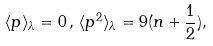<formula> <loc_0><loc_0><loc_500><loc_500>\langle p \rangle _ { \lambda } = 0 \, , \, \langle p ^ { 2 } \rangle _ { \lambda } = 9 ( n + \frac { 1 } { 2 } ) ,</formula> 